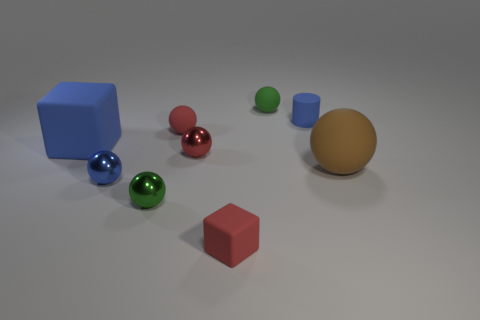Subtract all red balls. How many balls are left? 4 Subtract all blue shiny spheres. How many spheres are left? 5 Subtract all red spheres. Subtract all red cylinders. How many spheres are left? 4 Add 1 big yellow cubes. How many objects exist? 10 Subtract all cubes. How many objects are left? 7 Subtract all tiny green rubber balls. Subtract all brown things. How many objects are left? 7 Add 7 small cubes. How many small cubes are left? 8 Add 4 big blocks. How many big blocks exist? 5 Subtract 2 red spheres. How many objects are left? 7 